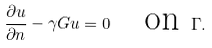<formula> <loc_0><loc_0><loc_500><loc_500>\frac { \partial u } { \partial n } - \gamma G u = 0 \quad \text {on } \Gamma .</formula> 